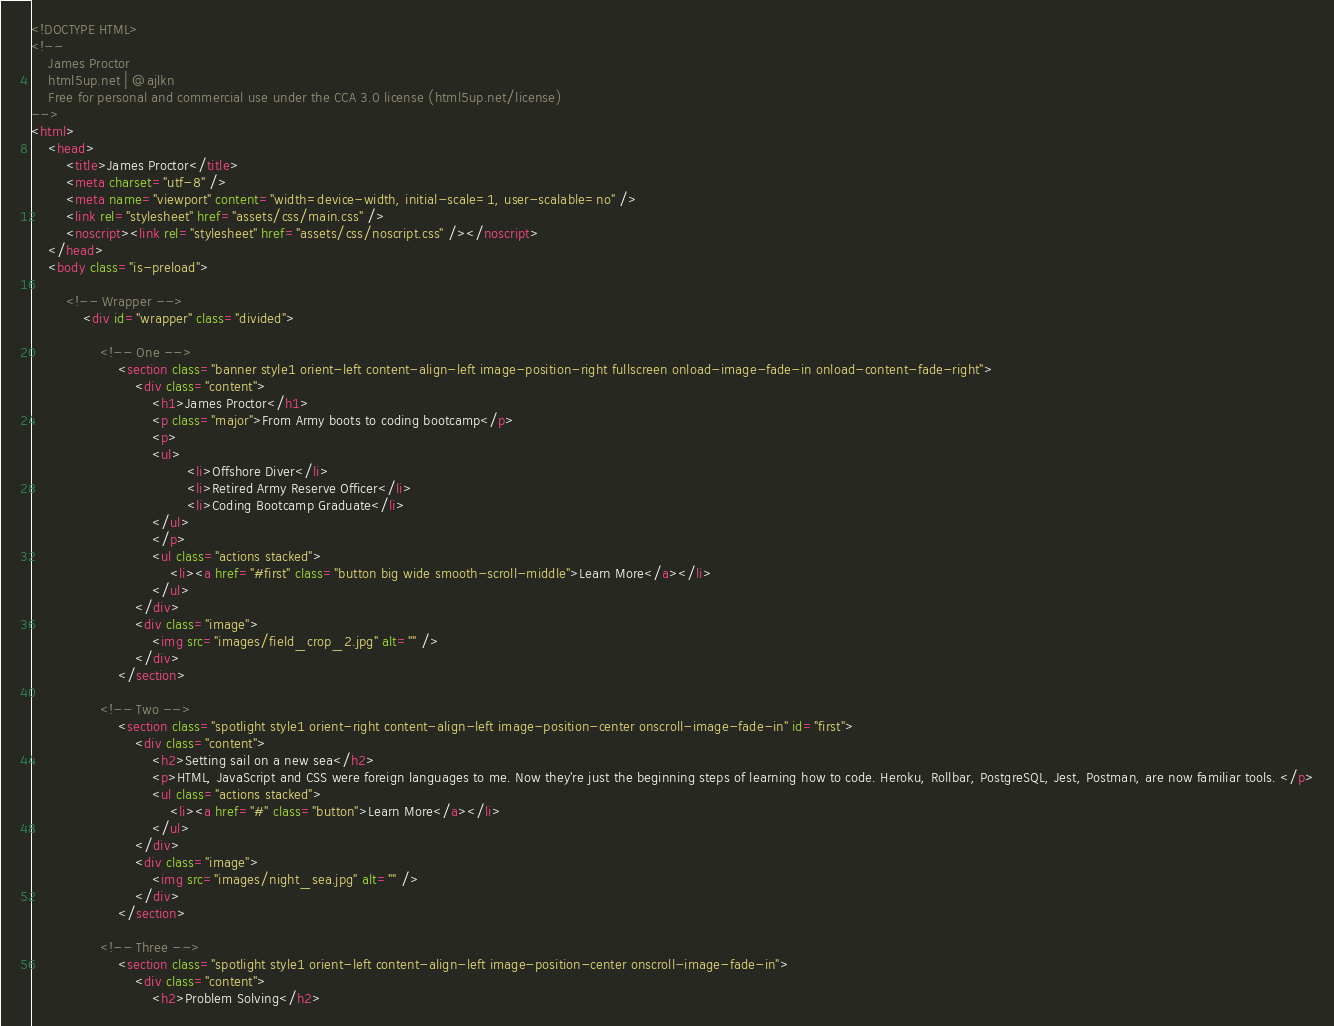Convert code to text. <code><loc_0><loc_0><loc_500><loc_500><_HTML_><!DOCTYPE HTML>
<!--
	James Proctor
	html5up.net | @ajlkn
	Free for personal and commercial use under the CCA 3.0 license (html5up.net/license)
-->
<html>
	<head>
		<title>James Proctor</title>
		<meta charset="utf-8" />
		<meta name="viewport" content="width=device-width, initial-scale=1, user-scalable=no" />
		<link rel="stylesheet" href="assets/css/main.css" />
		<noscript><link rel="stylesheet" href="assets/css/noscript.css" /></noscript>
	</head>
	<body class="is-preload">

		<!-- Wrapper -->
			<div id="wrapper" class="divided">

				<!-- One -->
					<section class="banner style1 orient-left content-align-left image-position-right fullscreen onload-image-fade-in onload-content-fade-right">
						<div class="content">
							<h1>James Proctor</h1>
							<p class="major">From Army boots to coding bootcamp</p>
							<p>
							<ul>
									<li>Offshore Diver</li>
									<li>Retired Army Reserve Officer</li>
									<li>Coding Bootcamp Graduate</li>
							</ul>
							</p>
							<ul class="actions stacked">
								<li><a href="#first" class="button big wide smooth-scroll-middle">Learn More</a></li>
							</ul>
						</div>
						<div class="image">
							<img src="images/field_crop_2.jpg" alt="" />
						</div>
					</section>

				<!-- Two -->
					<section class="spotlight style1 orient-right content-align-left image-position-center onscroll-image-fade-in" id="first">
						<div class="content">
							<h2>Setting sail on a new sea</h2>
							<p>HTML, JavaScript and CSS were foreign languages to me. Now they're just the beginning steps of learning how to code. Heroku, Rollbar, PostgreSQL, Jest, Postman, are now familiar tools. </p>
							<ul class="actions stacked">
								<li><a href="#" class="button">Learn More</a></li>
							</ul>
						</div>
						<div class="image">
							<img src="images/night_sea.jpg" alt="" />
						</div>
					</section>

				<!-- Three -->
					<section class="spotlight style1 orient-left content-align-left image-position-center onscroll-image-fade-in">
						<div class="content">
							<h2>Problem Solving</h2></code> 